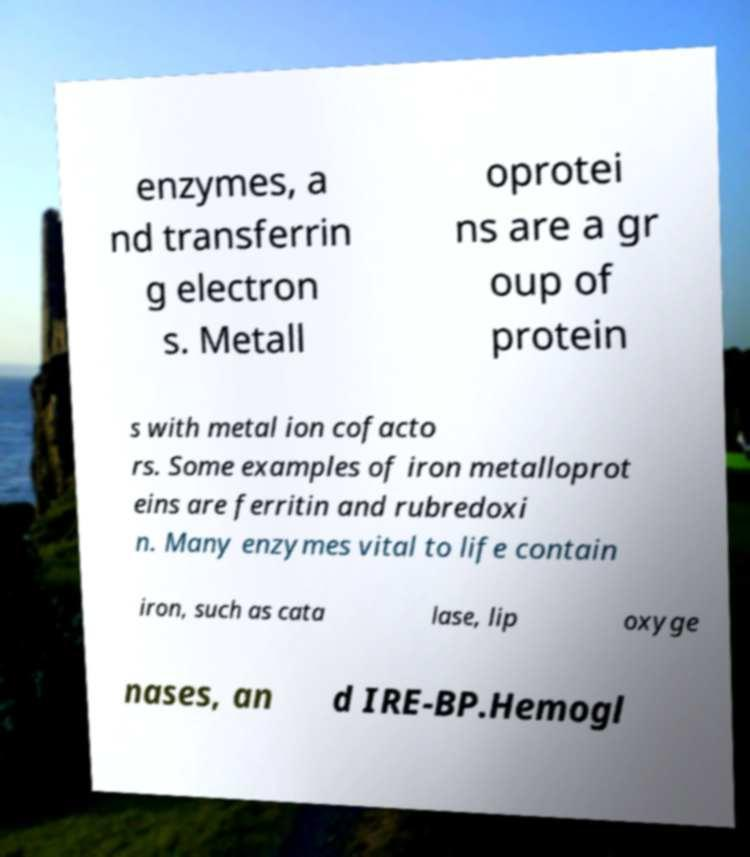Could you assist in decoding the text presented in this image and type it out clearly? enzymes, a nd transferrin g electron s. Metall oprotei ns are a gr oup of protein s with metal ion cofacto rs. Some examples of iron metalloprot eins are ferritin and rubredoxi n. Many enzymes vital to life contain iron, such as cata lase, lip oxyge nases, an d IRE-BP.Hemogl 